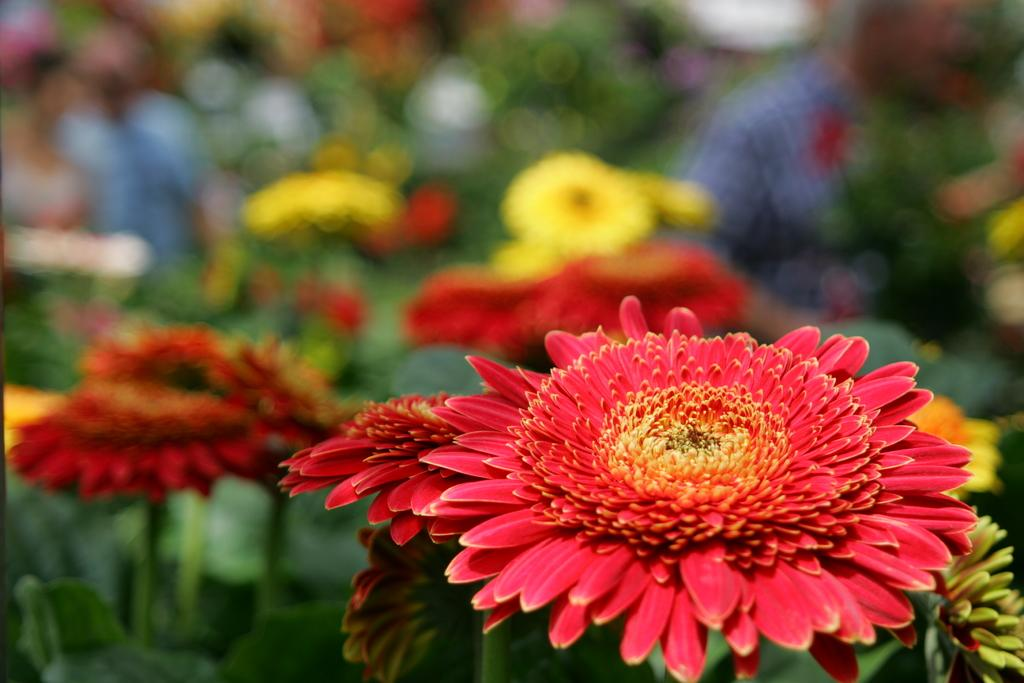What type of living organisms can be seen in the image? There are flowers in the image. What colors are the flowers in the image? Some flowers are red in red and yellow colors. What physical features do the flowers have? The flowers have petals. Are there any other plants associated with the flowers in the image? Yes, there are plants associated with the flowers. How many dogs are present in the image? There are no dogs present in the image; it features flowers and plants. 